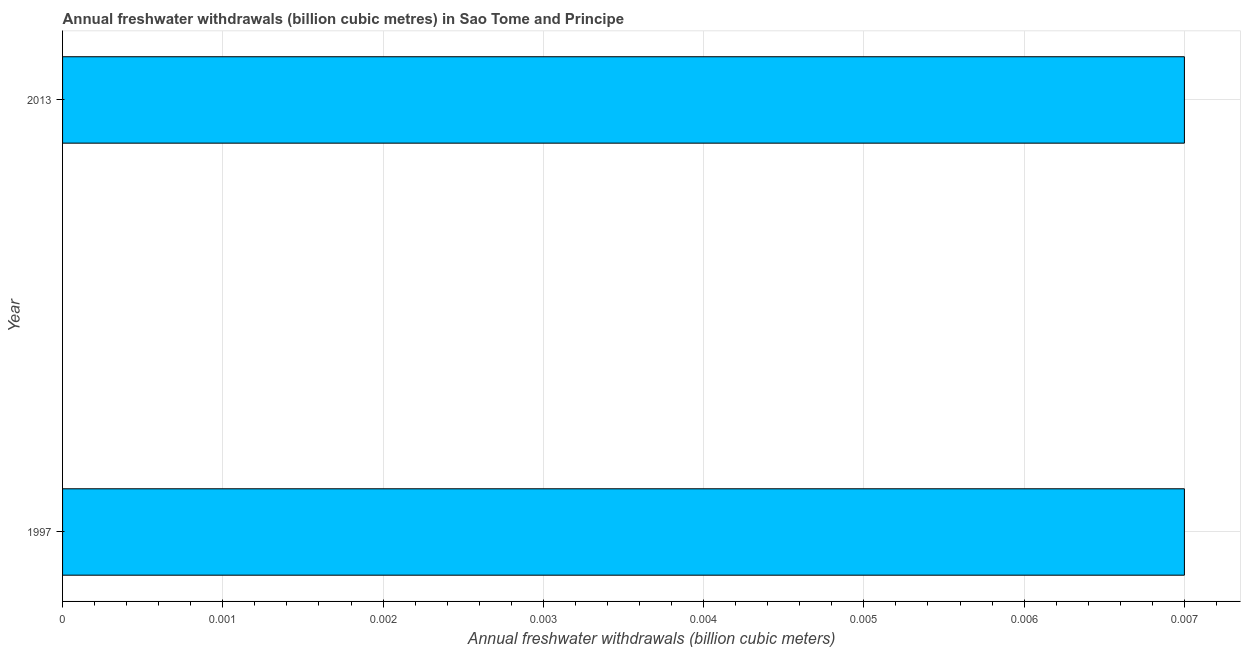What is the title of the graph?
Your answer should be very brief. Annual freshwater withdrawals (billion cubic metres) in Sao Tome and Principe. What is the label or title of the X-axis?
Your answer should be very brief. Annual freshwater withdrawals (billion cubic meters). What is the annual freshwater withdrawals in 1997?
Offer a terse response. 0.01. Across all years, what is the maximum annual freshwater withdrawals?
Give a very brief answer. 0.01. Across all years, what is the minimum annual freshwater withdrawals?
Provide a short and direct response. 0.01. In which year was the annual freshwater withdrawals maximum?
Your response must be concise. 1997. What is the sum of the annual freshwater withdrawals?
Make the answer very short. 0.01. What is the average annual freshwater withdrawals per year?
Make the answer very short. 0.01. What is the median annual freshwater withdrawals?
Offer a very short reply. 0.01. Do a majority of the years between 1997 and 2013 (inclusive) have annual freshwater withdrawals greater than 0.0024 billion cubic meters?
Ensure brevity in your answer.  Yes. Are all the bars in the graph horizontal?
Ensure brevity in your answer.  Yes. How many years are there in the graph?
Give a very brief answer. 2. What is the Annual freshwater withdrawals (billion cubic meters) in 1997?
Offer a terse response. 0.01. What is the Annual freshwater withdrawals (billion cubic meters) of 2013?
Your answer should be very brief. 0.01. What is the difference between the Annual freshwater withdrawals (billion cubic meters) in 1997 and 2013?
Offer a very short reply. 0. 